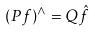<formula> <loc_0><loc_0><loc_500><loc_500>( P f ) ^ { \wedge } = Q \hat { f }</formula> 